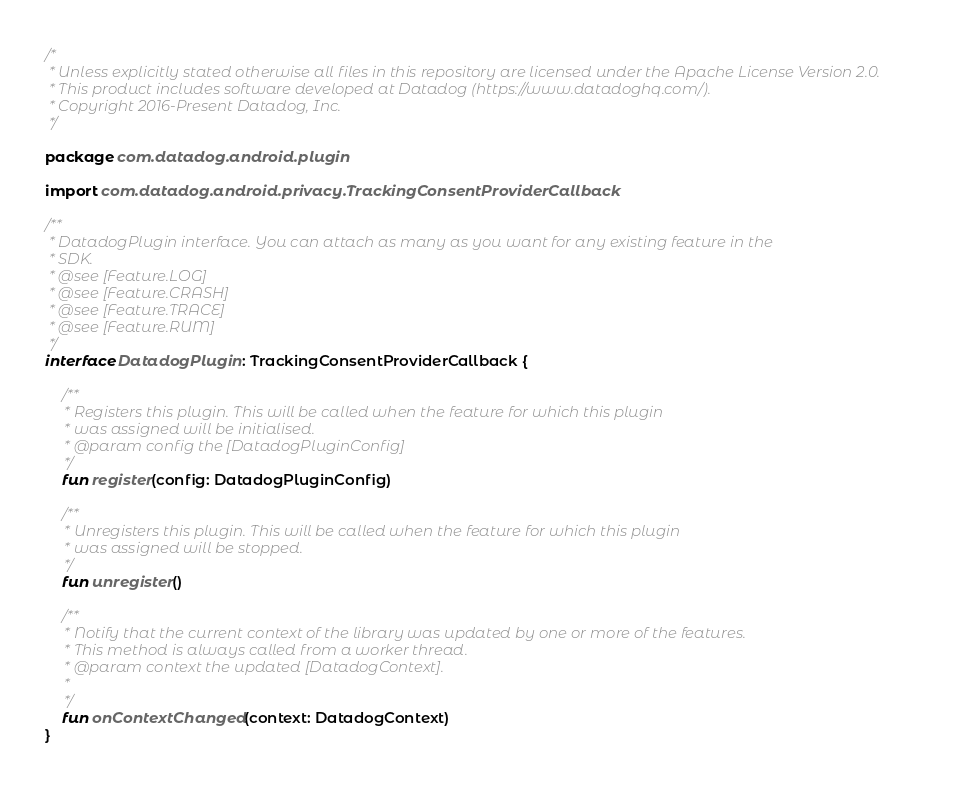<code> <loc_0><loc_0><loc_500><loc_500><_Kotlin_>/*
 * Unless explicitly stated otherwise all files in this repository are licensed under the Apache License Version 2.0.
 * This product includes software developed at Datadog (https://www.datadoghq.com/).
 * Copyright 2016-Present Datadog, Inc.
 */

package com.datadog.android.plugin

import com.datadog.android.privacy.TrackingConsentProviderCallback

/**
 * DatadogPlugin interface. You can attach as many as you want for any existing feature in the
 * SDK.
 * @see [Feature.LOG]
 * @see [Feature.CRASH]
 * @see [Feature.TRACE]
 * @see [Feature.RUM]
 */
interface DatadogPlugin : TrackingConsentProviderCallback {

    /**
     * Registers this plugin. This will be called when the feature for which this plugin
     * was assigned will be initialised.
     * @param config the [DatadogPluginConfig]
     */
    fun register(config: DatadogPluginConfig)

    /**
     * Unregisters this plugin. This will be called when the feature for which this plugin
     * was assigned will be stopped.
     */
    fun unregister()

    /**
     * Notify that the current context of the library was updated by one or more of the features.
     * This method is always called from a worker thread.
     * @param context the updated [DatadogContext].
     *
     */
    fun onContextChanged(context: DatadogContext)
}
</code> 